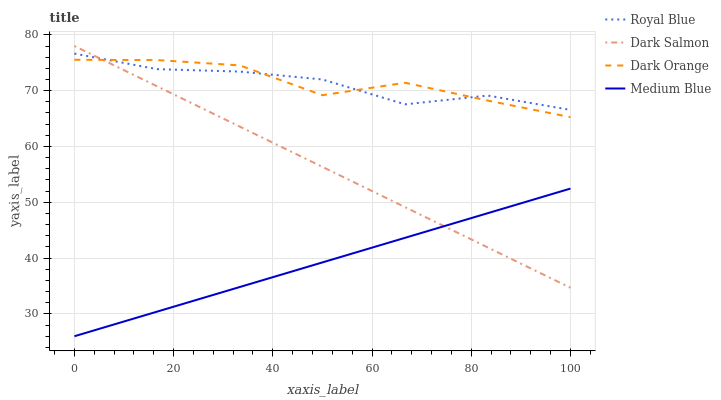Does Medium Blue have the minimum area under the curve?
Answer yes or no. Yes. Does Dark Orange have the maximum area under the curve?
Answer yes or no. Yes. Does Dark Salmon have the minimum area under the curve?
Answer yes or no. No. Does Dark Salmon have the maximum area under the curve?
Answer yes or no. No. Is Dark Salmon the smoothest?
Answer yes or no. Yes. Is Dark Orange the roughest?
Answer yes or no. Yes. Is Medium Blue the smoothest?
Answer yes or no. No. Is Medium Blue the roughest?
Answer yes or no. No. Does Medium Blue have the lowest value?
Answer yes or no. Yes. Does Dark Salmon have the lowest value?
Answer yes or no. No. Does Dark Salmon have the highest value?
Answer yes or no. Yes. Does Medium Blue have the highest value?
Answer yes or no. No. Is Medium Blue less than Dark Orange?
Answer yes or no. Yes. Is Royal Blue greater than Medium Blue?
Answer yes or no. Yes. Does Dark Orange intersect Royal Blue?
Answer yes or no. Yes. Is Dark Orange less than Royal Blue?
Answer yes or no. No. Is Dark Orange greater than Royal Blue?
Answer yes or no. No. Does Medium Blue intersect Dark Orange?
Answer yes or no. No. 